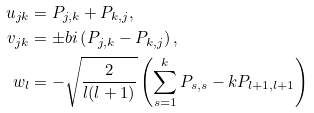Convert formula to latex. <formula><loc_0><loc_0><loc_500><loc_500>u _ { j k } & = P _ { j , k } + P _ { k , j } , \\ v _ { j k } & = \pm b { i } \left ( P _ { j , k } - P _ { k , j } \right ) , \\ w _ { l } & = - \sqrt { \frac { 2 } { l ( l + 1 ) } } \left ( \sum _ { s = 1 } ^ { k } P _ { s , s } - k P _ { l + 1 , l + 1 } \right )</formula> 